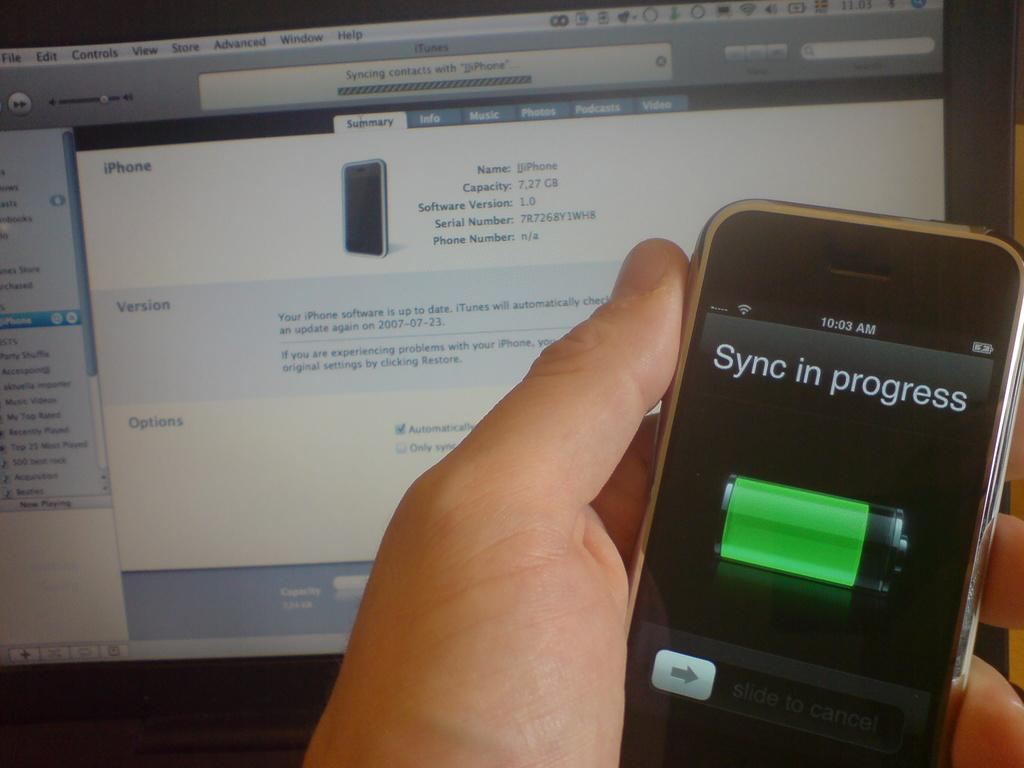<image>
Share a concise interpretation of the image provided. A person holds an Iphone with a sync in progress. 